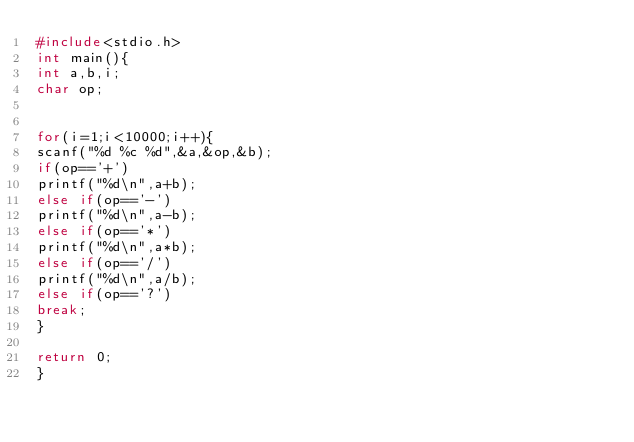<code> <loc_0><loc_0><loc_500><loc_500><_C_>#include<stdio.h>
int main(){
int a,b,i;
char op;


for(i=1;i<10000;i++){
scanf("%d %c %d",&a,&op,&b);
if(op=='+') 
printf("%d\n",a+b);
else if(op=='-') 
printf("%d\n",a-b);
else if(op=='*')
printf("%d\n",a*b);
else if(op=='/')
printf("%d\n",a/b);
else if(op=='?')
break;
}

return 0;
}
</code> 